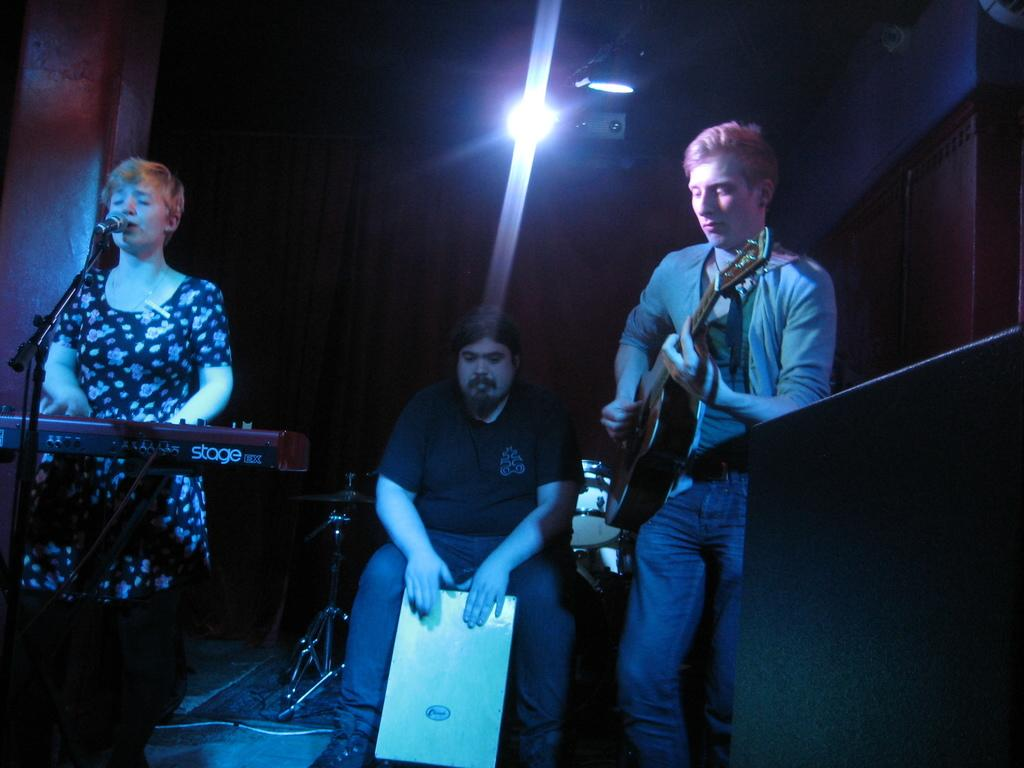How many people are in the image? There are people in the image, but the exact number is not specified in the facts. What are some of the people doing in the image? Some of the people are standing, and some of them are holding guitars. What instrument is the person playing in the image? The person is playing a Casio in the image. Can you describe the seating arrangement of the people in the image? There is a person sitting in between the standing people and the person playing the Casio. What type of pen is the person holding in the image? There is no pen present in the image. What order are the people standing in, from left to right? The facts do not provide enough information to determine the order of the people from left to right. --- Facts: 1. There is a person sitting on a chair in the image. 2. The person is holding a book. 3. The book has a blue cover. 4. There is a table next to the chair. 5. There is a lamp on the table. Absurd Topics: parrot, ocean, bicycle Conversation: What is the person in the image doing? The person is sitting on a chair in the image. What is the person holding in the image? The person is holding a book in the image. What color is the book's cover? The book has a blue cover. What is located next to the chair in the image? There is a table next to the chair in the image. What object is on the table in the image? There is a lamp on the table in the image. Reasoning: Let's think step by step in order to produce the conversation. We start by describing the main subject in the image, which is the person sitting on a chair. Then, we expand the conversation to include the book the person is holding, focusing on its color. Next, we describe the table and the lamp on it, which are also mentioned in the facts. Absurd Question/Answer: Can you see a parrot sitting on the person's shoulder in the image? No, there is no parrot present in the image. What type of ocean can be seen in the background of the image? There is no ocean visible in the image. 